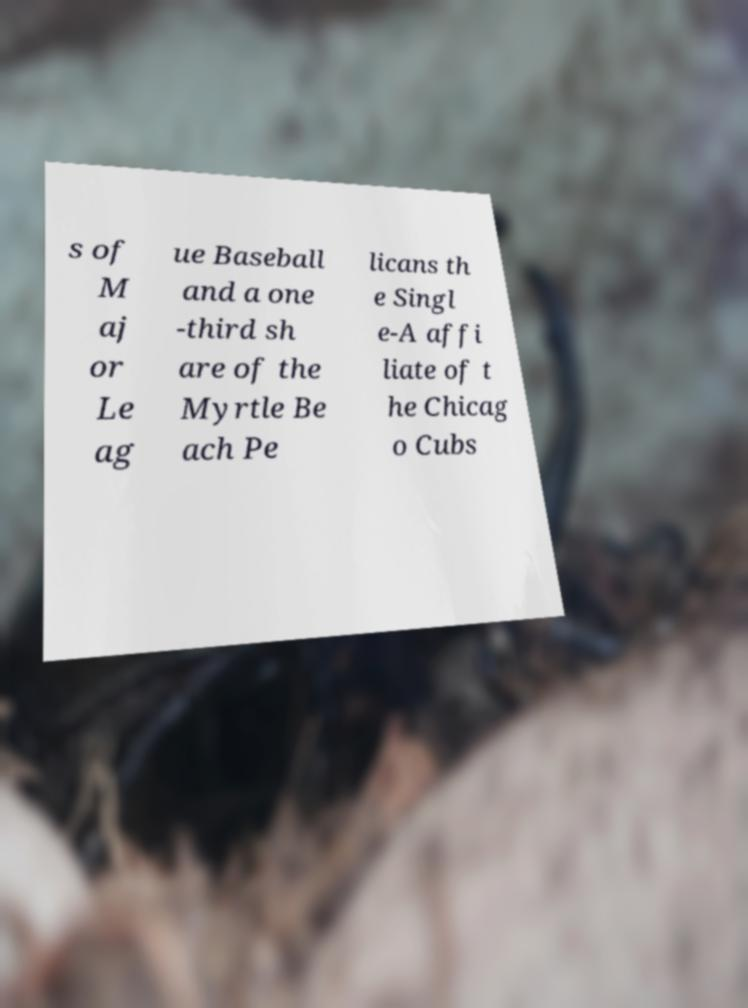For documentation purposes, I need the text within this image transcribed. Could you provide that? s of M aj or Le ag ue Baseball and a one -third sh are of the Myrtle Be ach Pe licans th e Singl e-A affi liate of t he Chicag o Cubs 